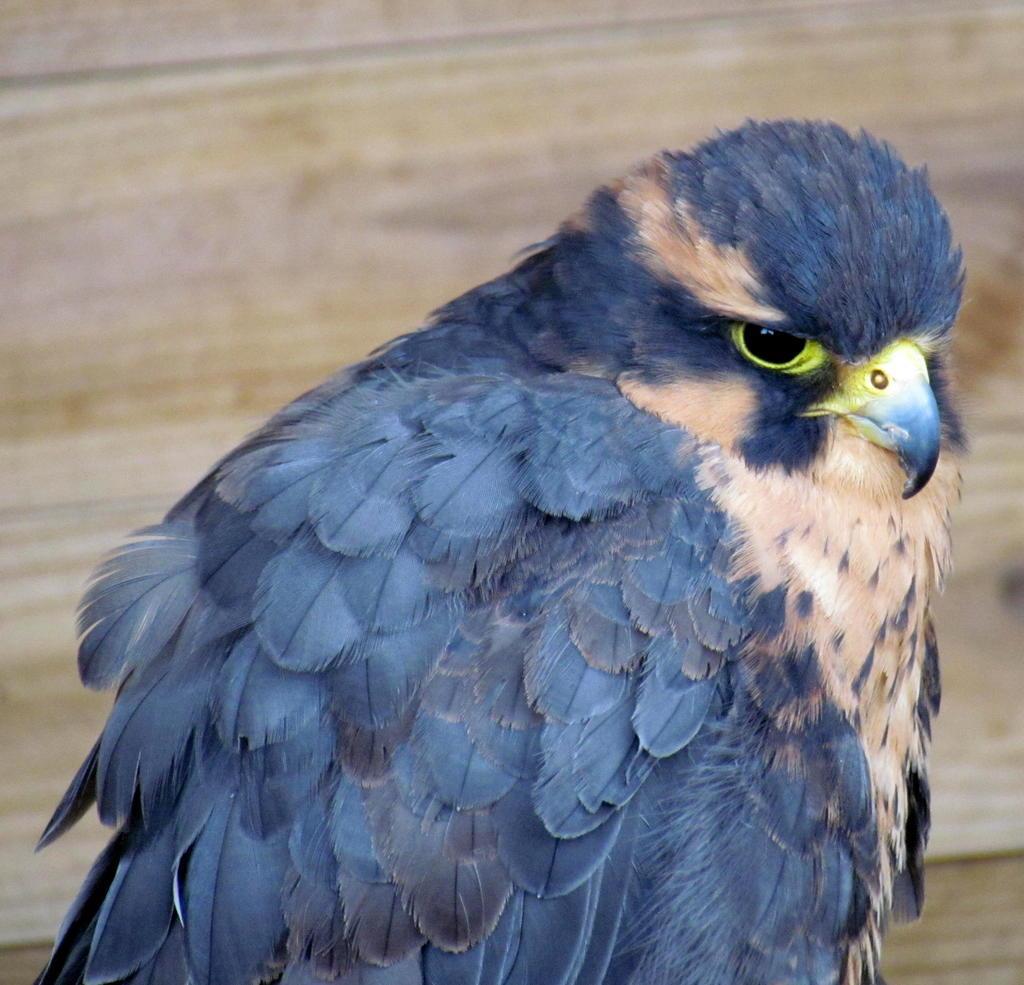Could you give a brief overview of what you see in this image? In this picture we can see a bird. In the background of the image it is blurry. 